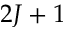<formula> <loc_0><loc_0><loc_500><loc_500>2 J + 1</formula> 